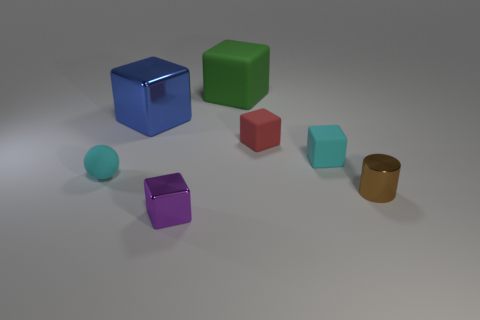What material is the tiny brown cylinder?
Offer a very short reply. Metal. What color is the rubber object left of the small purple metallic object?
Provide a short and direct response. Cyan. What number of big metallic things are the same color as the tiny metal cylinder?
Provide a short and direct response. 0. How many small objects are both right of the cyan cube and on the left side of the red thing?
Keep it short and to the point. 0. There is a brown metal object that is the same size as the red matte thing; what shape is it?
Your answer should be compact. Cylinder. The red block is what size?
Offer a very short reply. Small. The cyan object in front of the cyan matte thing that is on the right side of the shiny block in front of the small brown cylinder is made of what material?
Provide a short and direct response. Rubber. There is a tiny block that is made of the same material as the large blue cube; what color is it?
Provide a succinct answer. Purple. There is a red cube right of the metallic thing behind the small cylinder; what number of small matte objects are in front of it?
Offer a very short reply. 2. There is a tiny object that is the same color as the tiny rubber sphere; what material is it?
Make the answer very short. Rubber. 